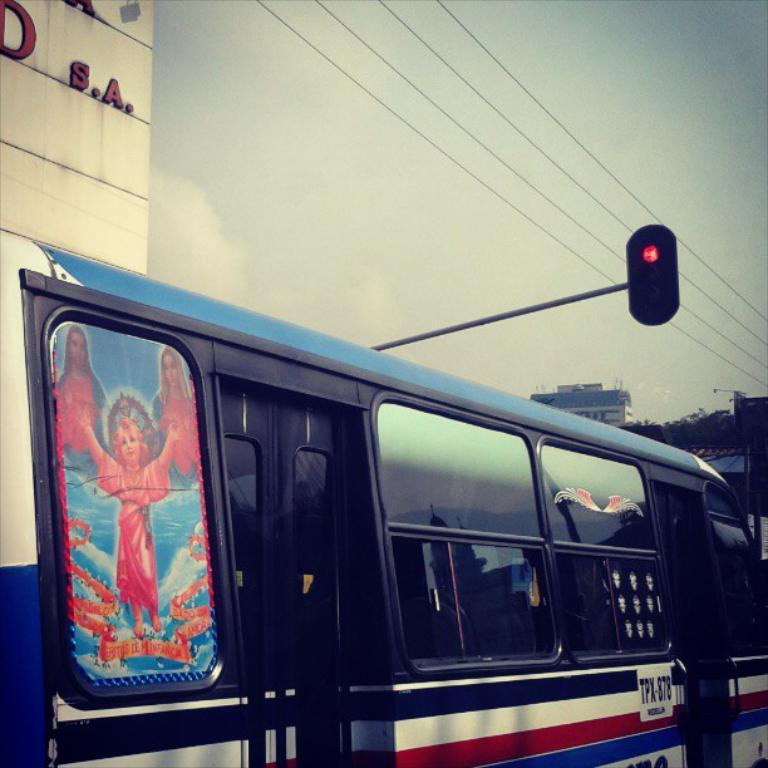What is the main subject in the foreground of the image? There is a bus in the foreground of the image. What is located above the bus in the image? There is a traffic signal light above the bus. What can be seen in the background of the image? There is a building in the background of the image. What type of joke can be heard coming from the secretary in the image? There is no secretary present in the image, so it's not possible to determine what, if any, joke might be heard. 